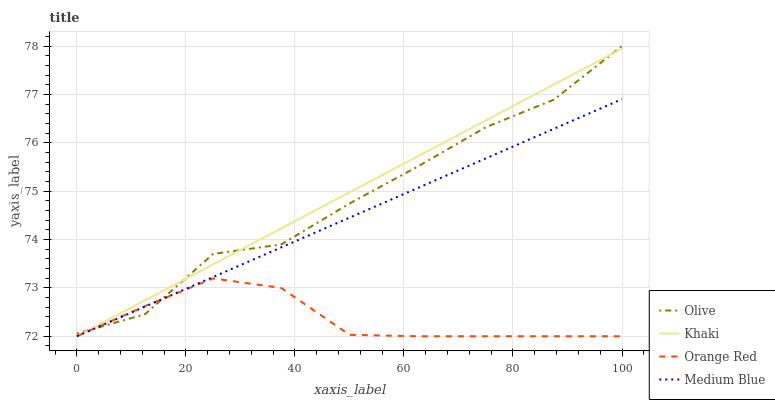Does Medium Blue have the minimum area under the curve?
Answer yes or no. No. Does Medium Blue have the maximum area under the curve?
Answer yes or no. No. Is Medium Blue the smoothest?
Answer yes or no. No. Is Medium Blue the roughest?
Answer yes or no. No. Does Khaki have the highest value?
Answer yes or no. No. 